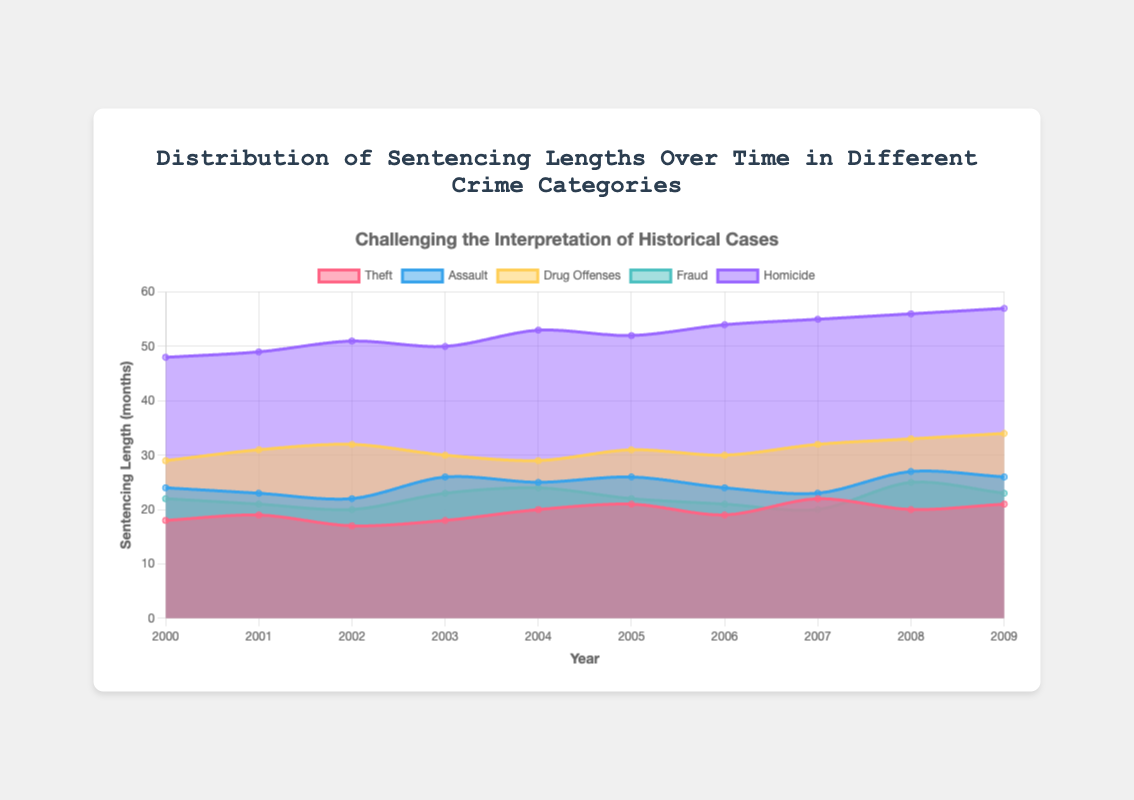What is the title of the chart? The title is located at the top of the chart and it states the main subject of the visualization.
Answer: Distribution of Sentencing Lengths Over Time in Different Crime Categories What years are covered in the chart? The x-axis of the chart lists the years included in the data.
Answer: 2000 to 2009 In which category did sentences increase most consistently over time? By examining the trend lines for each crime category, one can identify which has a steady upward trend.
Answer: Homicide How did the average sentence length for drug offenses change from 2000 to 2009? Calculate the average of sentences for drug offenses at the start (29 months in 2000) and the end (34 months in 2009).
Answer: Increased by 5 months Which crime category had the highest sentence length in 2004? Look at the data points for each category in the year 2004 to see which has the highest value.
Answer: Homicide What is the difference in sentencing length between homicide and theft in 2009? Find the sentences for homicide and theft in 2009, then subtract the theft sentence from the homicide sentence (57 - 21).
Answer: 36 months What year did assault have its highest sentencing length? Identify the year where the assault trend line reaches its peak.
Answer: 2008 By how much did the sentence length for fraud vary from its minimum to maximum over the years included? Subtract the minimum sentence length (20 months) from the maximum (25 months).
Answer: 5 months Which category had the least variation in sentencing length over the given years? The category with the smallest difference between its highest and lowest points likely has the least variation.
Answer: Fraud Is there any year where sentencing lengths for all crime categories were stable, meaning no significant fluctuations? Examine the year-to-year changes for all categories to identify any year with minimal fluctuations across all categories.
Answer: No, there are fluctuations every year 